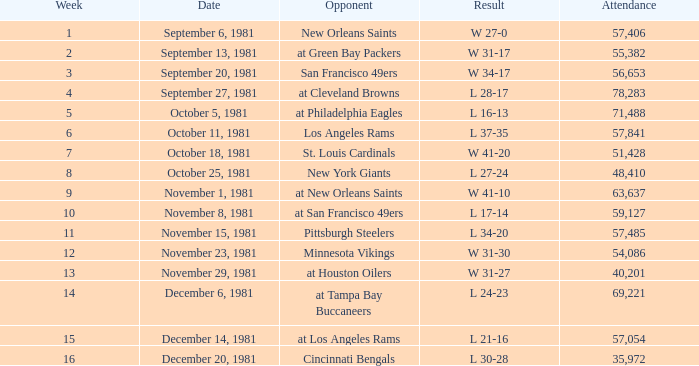Before october 8, what was the largest weekly attendance for the game on october 25, 1981? None. 